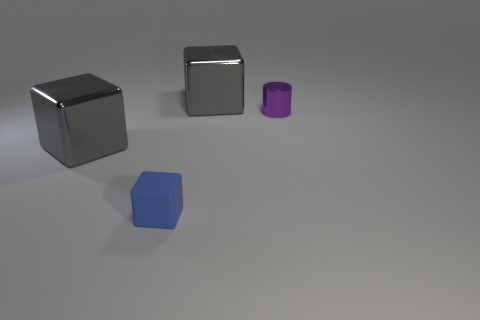Add 1 purple cylinders. How many objects exist? 5 Subtract all cylinders. How many objects are left? 3 Subtract all brown rubber cylinders. Subtract all tiny metal cylinders. How many objects are left? 3 Add 2 rubber cubes. How many rubber cubes are left? 3 Add 4 small red objects. How many small red objects exist? 4 Subtract 0 cyan cylinders. How many objects are left? 4 